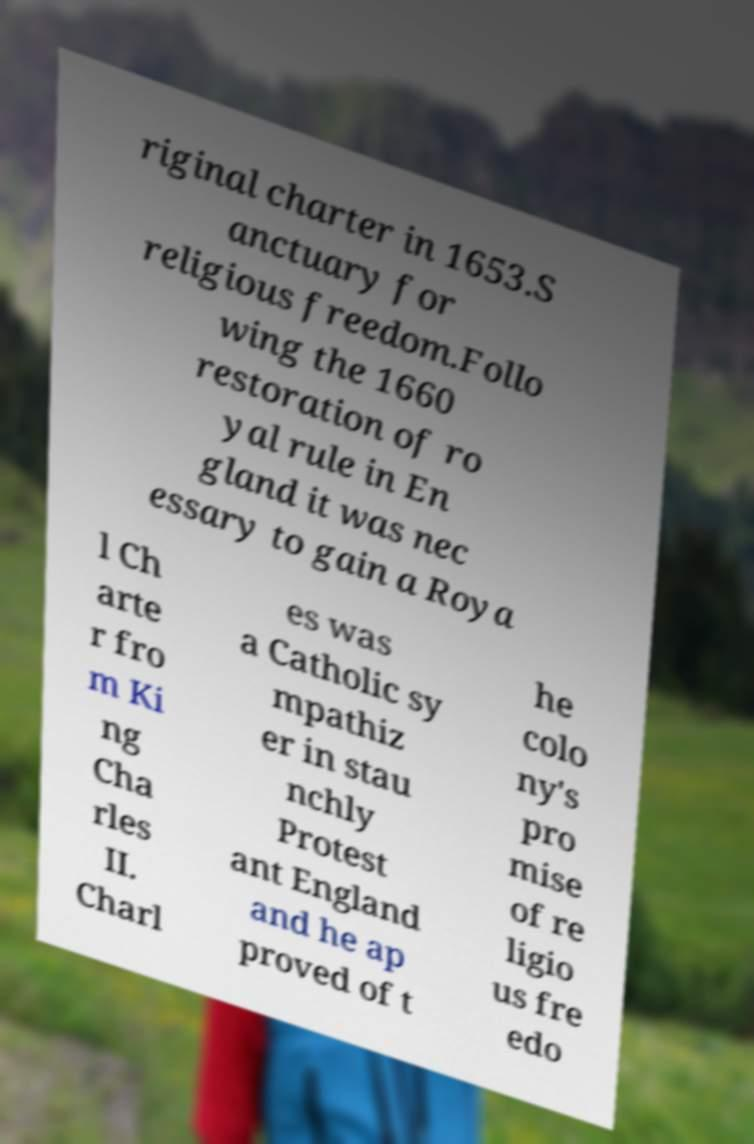For documentation purposes, I need the text within this image transcribed. Could you provide that? riginal charter in 1653.S anctuary for religious freedom.Follo wing the 1660 restoration of ro yal rule in En gland it was nec essary to gain a Roya l Ch arte r fro m Ki ng Cha rles II. Charl es was a Catholic sy mpathiz er in stau nchly Protest ant England and he ap proved of t he colo ny's pro mise of re ligio us fre edo 